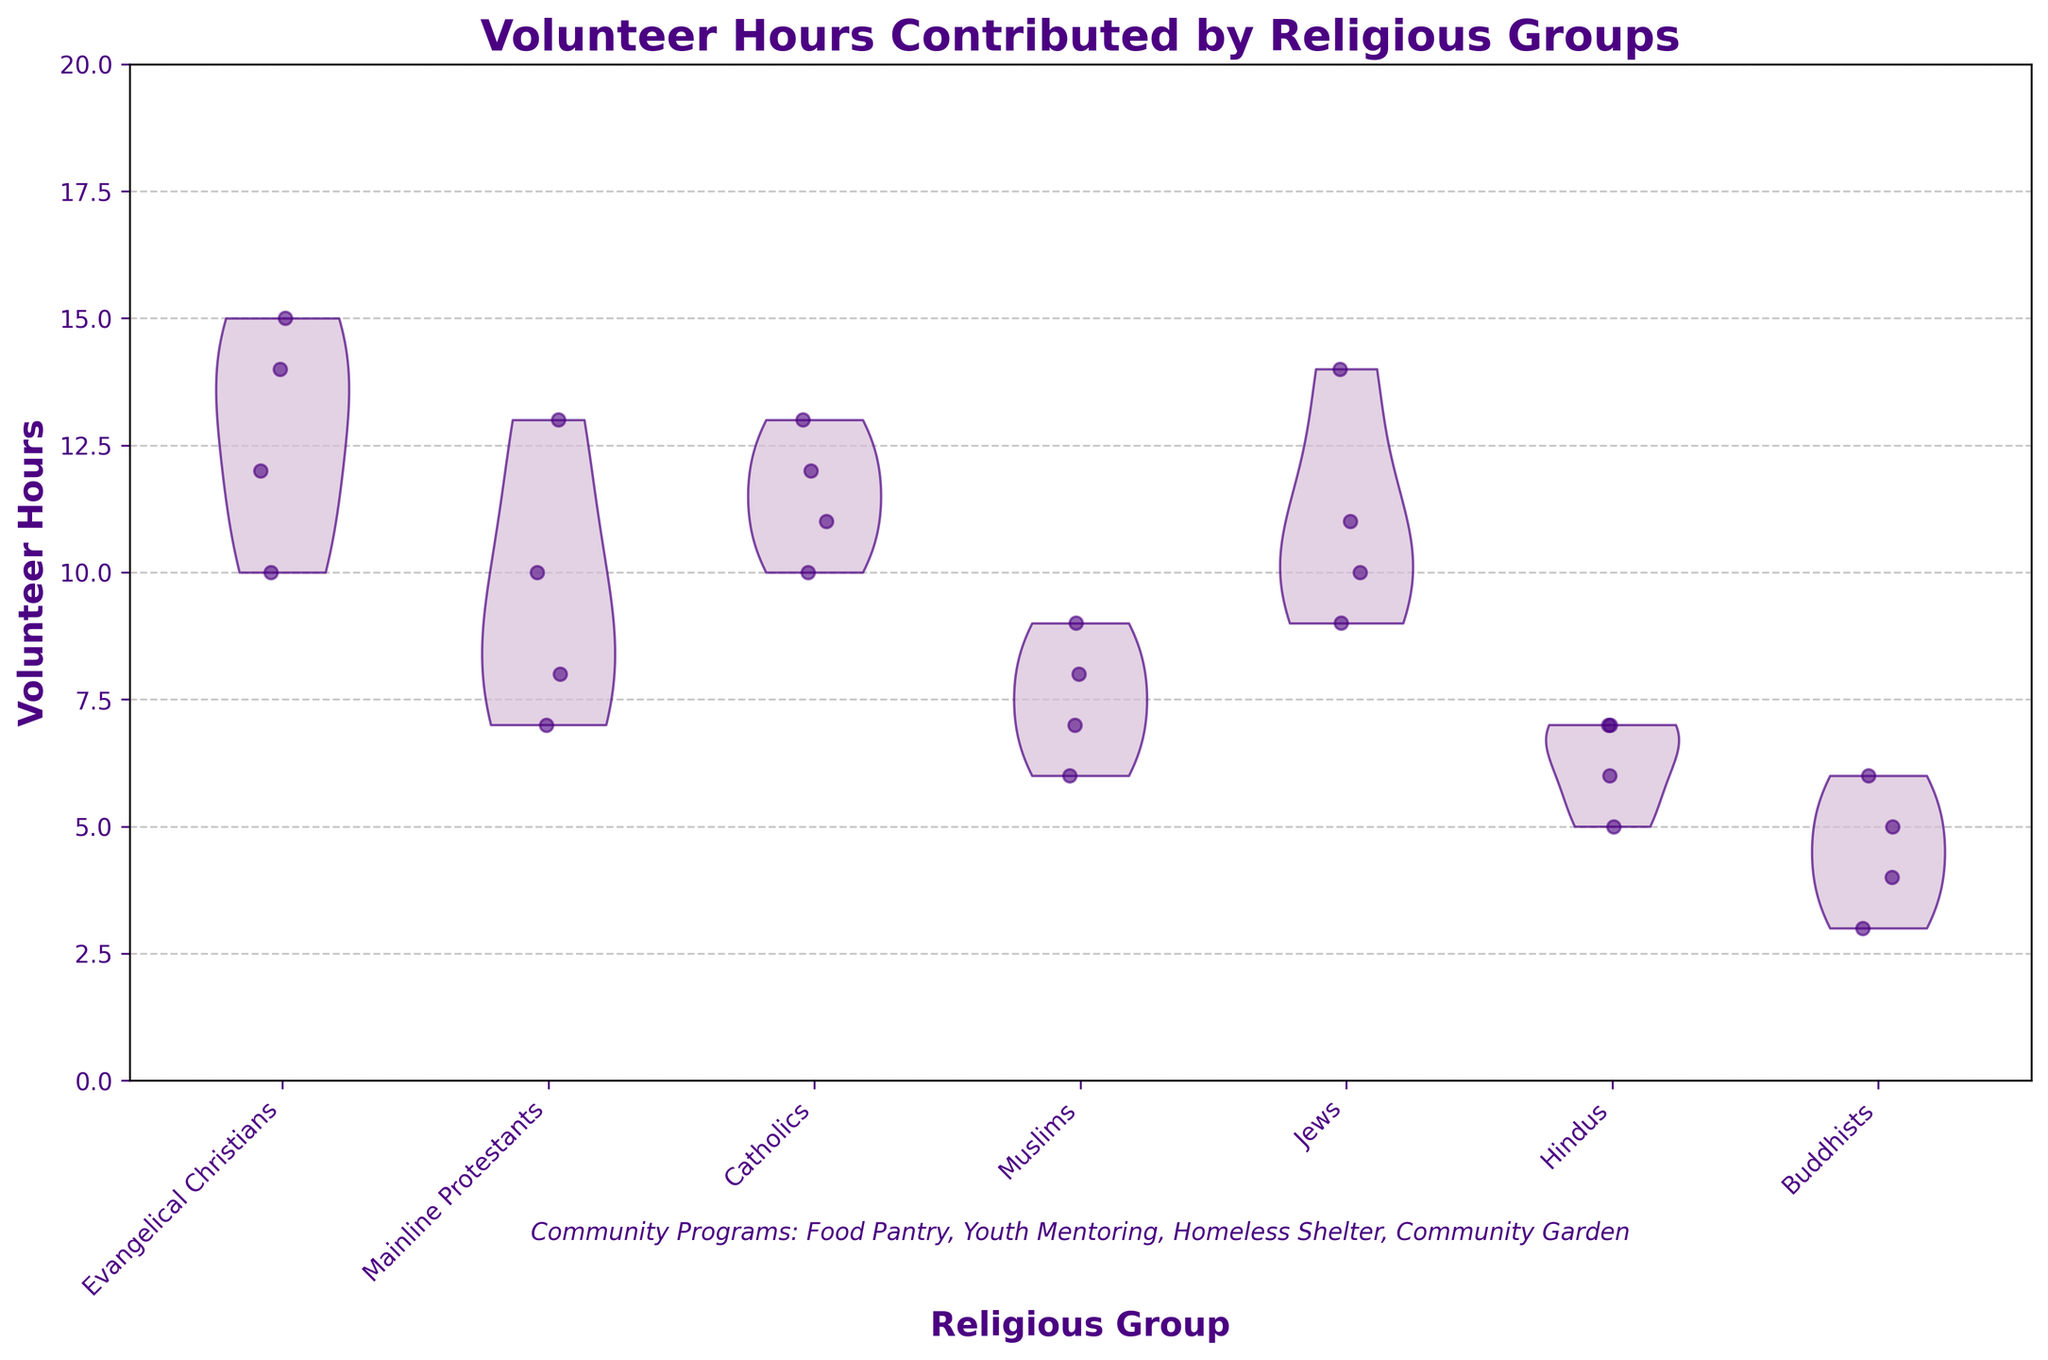What's the title of the chart? The title is usually located at the top of the chart. In this case, it reads 'Volunteer Hours Contributed by Religious Groups'.
Answer: Volunteer Hours Contributed by Religious Groups How many religious groups are represented in the chart? The x-axis labels show the different religious groups. There are labels for Evangelical Christians, Mainline Protestants, Catholics, Muslims, Jews, Hindus, and Buddhists. Counting these gives a total of 7 groups.
Answer: 7 Which religious group shows the widest spread in volunteer hours? The width of the violin plot indicates the spread of volunteer hours. The spread for Evangelical Christians appears to be the widest, indicating high variability in their volunteer hours.
Answer: Evangelical Christians Which two religious groups contribute the least volunteer hours? By observing the range and density of the violin plots, it's noticeable that Buddhists and Hindus have the lowest volunteer hours with their plots concentrated at the lower end of the y-axis.
Answer: Buddhists and Hindus What is the range of volunteer hours for Catholics? The violin plot and jittered points provide the distribution of volunteer hours. For Catholics, the points are mostly between 10 and 13 hours. Hence, the range is from the minimum to the maximum points visible.
Answer: 10 to 13 hours Which community program has been mentioned in the additional information text at the bottom of the chart? The text at the bottom of the chart lists the community programs included in the data. It mentions Food Pantry, Youth Mentoring, Homeless Shelter, and Community Garden.
Answer: Food Pantry, Youth Mentoring, Homeless Shelter, Community Garden How do Muslims' volunteer hours compare to those of Jews? By comparing the violin plots of Muslims and Jews, Jews generally contribute more volunteer hours than Muslims, as their plot is centered higher on the y-axis than that of Muslims.
Answer: Jews volunteer more hours Estimate the average volunteer hours for Mainline Protestants. We would estimate the average by visually identifying the center point of the distribution. For Mainline Protestants, the jittered points cluster around 9 to 10 hours on average.
Answer: 9 to 10 hours What color and style are used for the violin plot in this chart? The violin plots have a light purple color ('#D8BFD8') with dark purple edges ('#4B0082'). The alpha transparency is set to 0.7, giving them a semi-transparent appearance.
Answer: Light purple with dark purple edges 